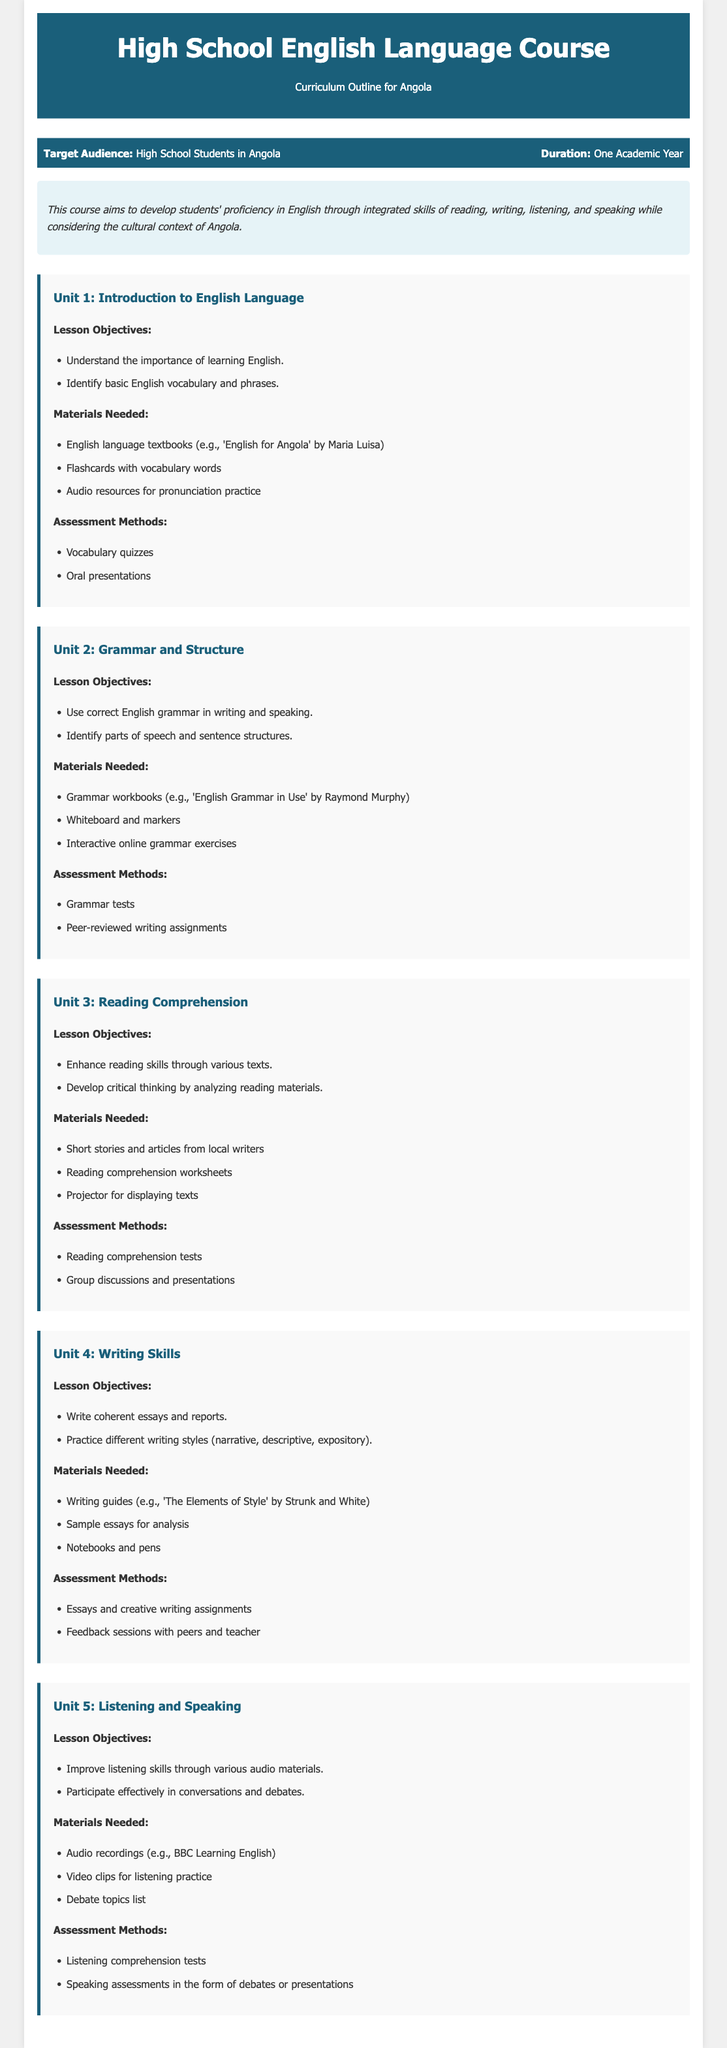What is the target audience for the course? The target audience is specified in the document, which is high school students in Angola.
Answer: High School Students in Angola How long is the duration of the course? The document states that the course duration is one academic year.
Answer: One Academic Year What is one of the lesson objectives of Unit 1? The document lists lesson objectives for each unit; one is to understand the importance of learning English.
Answer: Understand the importance of learning English What materials are needed for Unit 2? The document includes a list of materials for each unit; Unit 2 requires grammar workbooks, a whiteboard, and interactive exercises.
Answer: Grammar workbooks, whiteboard, interactive online grammar exercises What type of assessment method is used in Unit 4? Assessment methods are specified for each unit, and Unit 4 includes essays and creative writing assignments.
Answer: Essays and creative writing assignments Name one topic covered in Unit 5. The document outlines lesson objectives for each unit; Unit 5 focuses on improving listening skills and participating in conversations and debates.
Answer: Listening skills How many units are outlined in this curriculum? By counting the units listed in the document, there are five units outlined in the curriculum.
Answer: Five What is the main aim of the course? The document summarizes the course's objective, which is to develop students' proficiency in English.
Answer: Develop students' proficiency in English 